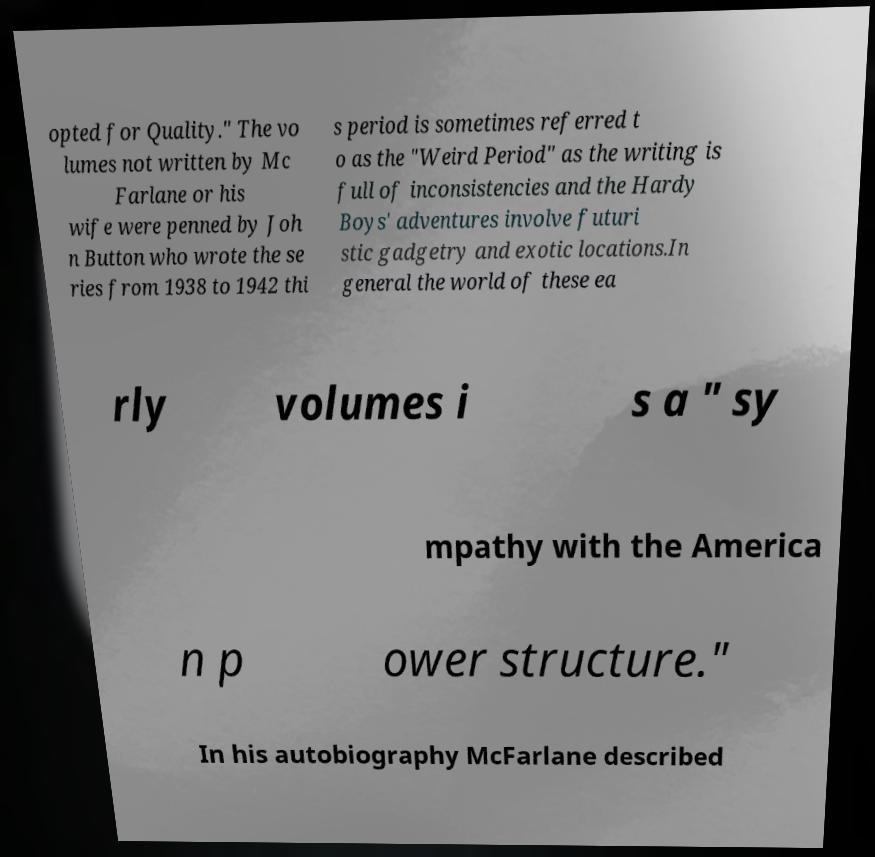Could you extract and type out the text from this image? opted for Quality." The vo lumes not written by Mc Farlane or his wife were penned by Joh n Button who wrote the se ries from 1938 to 1942 thi s period is sometimes referred t o as the "Weird Period" as the writing is full of inconsistencies and the Hardy Boys' adventures involve futuri stic gadgetry and exotic locations.In general the world of these ea rly volumes i s a " sy mpathy with the America n p ower structure." In his autobiography McFarlane described 